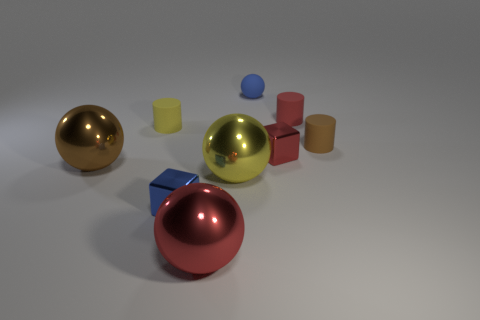Subtract all small spheres. How many spheres are left? 3 Subtract all yellow cylinders. How many cylinders are left? 2 Subtract all balls. How many objects are left? 5 Add 5 red shiny cubes. How many red shiny cubes are left? 6 Add 1 yellow matte cylinders. How many yellow matte cylinders exist? 2 Subtract 0 cyan blocks. How many objects are left? 9 Subtract 1 cubes. How many cubes are left? 1 Subtract all green cubes. Subtract all brown cylinders. How many cubes are left? 2 Subtract all tiny red shiny cubes. Subtract all large red rubber spheres. How many objects are left? 8 